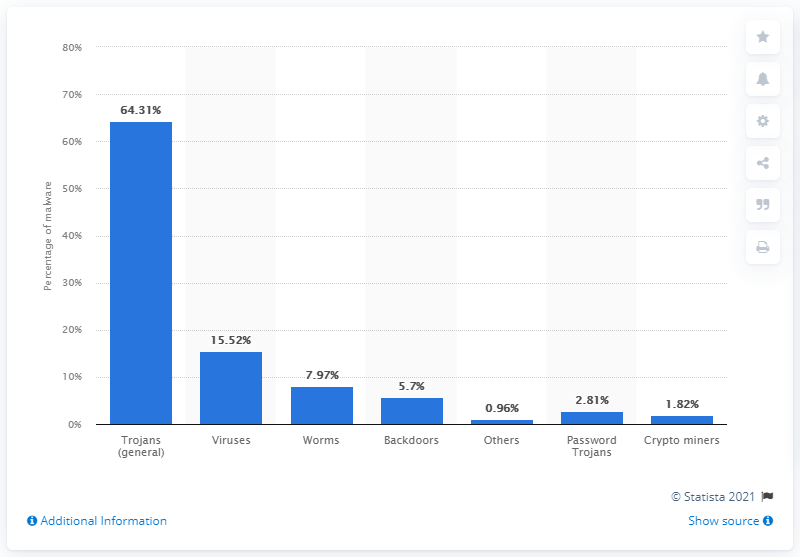Draw attention to some important aspects in this diagram. In 2019, viruses accounted for approximately 15.52% of all malware attacks. In 2019, trojans accounted for approximately 64.31% of all malware attacks on Windows systems. 